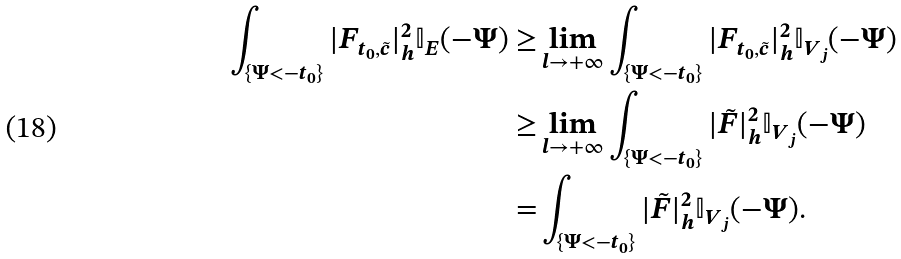<formula> <loc_0><loc_0><loc_500><loc_500>\int _ { \{ \Psi < - t _ { 0 } \} } | F _ { t _ { 0 } , \tilde { c } } | ^ { 2 } _ { h } \mathbb { I } _ { E } ( - \Psi ) \geq & \lim _ { l \to + \infty } \int _ { \{ \Psi < - t _ { 0 } \} } | F _ { t _ { 0 } , \tilde { c } } | ^ { 2 } _ { h } \mathbb { I } _ { V _ { j } } ( - \Psi ) \\ \geq & \lim _ { l \to + \infty } \int _ { \{ \Psi < - t _ { 0 } \} } | \tilde { F } | ^ { 2 } _ { h } \mathbb { I } _ { V _ { j } } ( - \Psi ) \\ = & \int _ { \{ \Psi < - t _ { 0 } \} } | \tilde { F } | ^ { 2 } _ { h } \mathbb { I } _ { V _ { j } } ( - \Psi ) .</formula> 